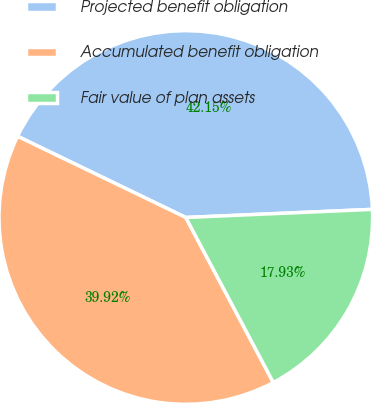Convert chart to OTSL. <chart><loc_0><loc_0><loc_500><loc_500><pie_chart><fcel>Projected benefit obligation<fcel>Accumulated benefit obligation<fcel>Fair value of plan assets<nl><fcel>42.15%<fcel>39.92%<fcel>17.93%<nl></chart> 